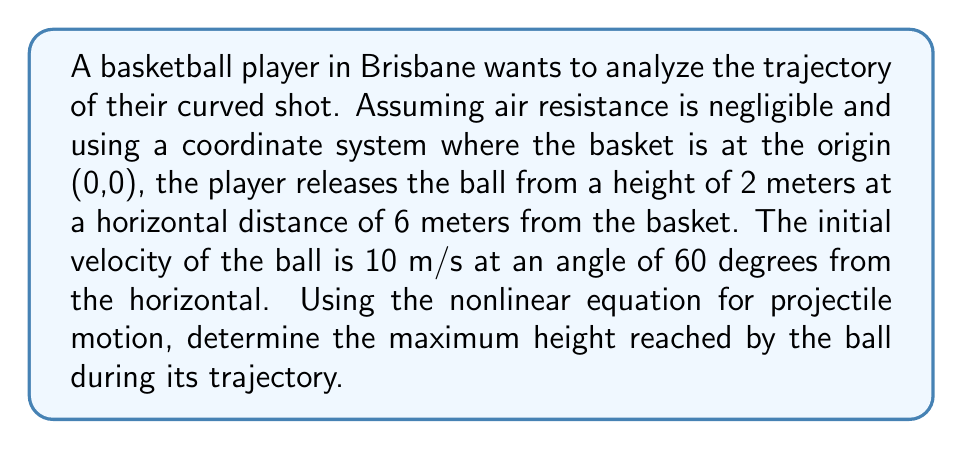Solve this math problem. To solve this problem, we'll use the equations of motion for projectile motion, which are nonlinear due to the parabolic nature of the trajectory.

Step 1: Define the initial conditions
- Initial height: $y_0 = 2$ m
- Initial horizontal distance: $x_0 = -6$ m (since the basket is at the origin)
- Initial velocity: $v_0 = 10$ m/s
- Angle of release: $\theta = 60°$
- Acceleration due to gravity: $g = 9.8$ m/s²

Step 2: Break down the initial velocity into x and y components
$v_{0x} = v_0 \cos(\theta) = 10 \cos(60°) = 5$ m/s
$v_{0y} = v_0 \sin(\theta) = 10 \sin(60°) = 8.66$ m/s

Step 3: Use the equation for the y-coordinate of the ball's position
$$y(t) = y_0 + v_{0y}t - \frac{1}{2}gt^2$$

Step 4: To find the maximum height, we need to find when the vertical velocity is zero
$v_y(t) = v_{0y} - gt = 0$
$t_{max} = \frac{v_{0y}}{g} = \frac{8.66}{9.8} = 0.884$ seconds

Step 5: Substitute this time into the y-coordinate equation to find the maximum height
$$y_{max} = y_0 + v_{0y}t_{max} - \frac{1}{2}gt_{max}^2$$
$$y_{max} = 2 + 8.66(0.884) - \frac{1}{2}(9.8)(0.884)^2$$
$$y_{max} = 2 + 7.66 - 3.83 = 5.83$ meters

Therefore, the maximum height reached by the ball is 5.83 meters.
Answer: 5.83 meters 